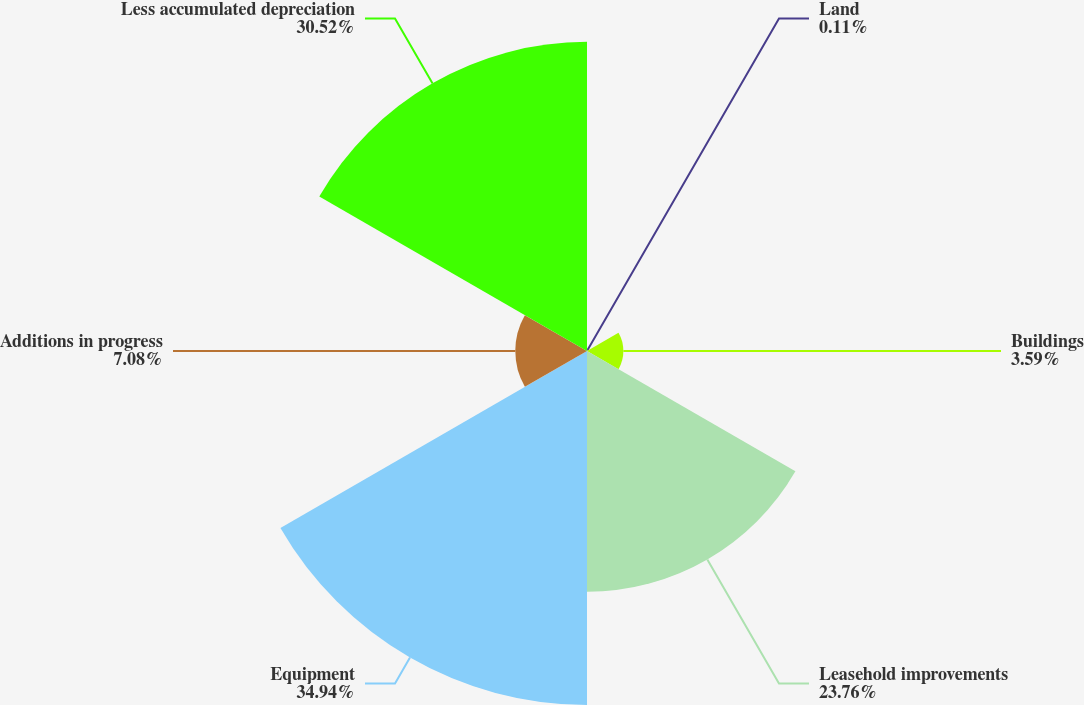Convert chart to OTSL. <chart><loc_0><loc_0><loc_500><loc_500><pie_chart><fcel>Land<fcel>Buildings<fcel>Leasehold improvements<fcel>Equipment<fcel>Additions in progress<fcel>Less accumulated depreciation<nl><fcel>0.11%<fcel>3.59%<fcel>23.76%<fcel>34.95%<fcel>7.08%<fcel>30.52%<nl></chart> 